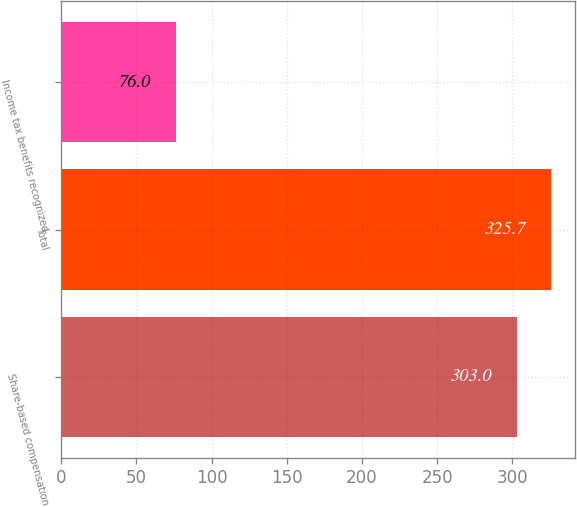Convert chart to OTSL. <chart><loc_0><loc_0><loc_500><loc_500><bar_chart><fcel>Share-based compensation<fcel>Total<fcel>Income tax benefits recognized<nl><fcel>303<fcel>325.7<fcel>76<nl></chart> 